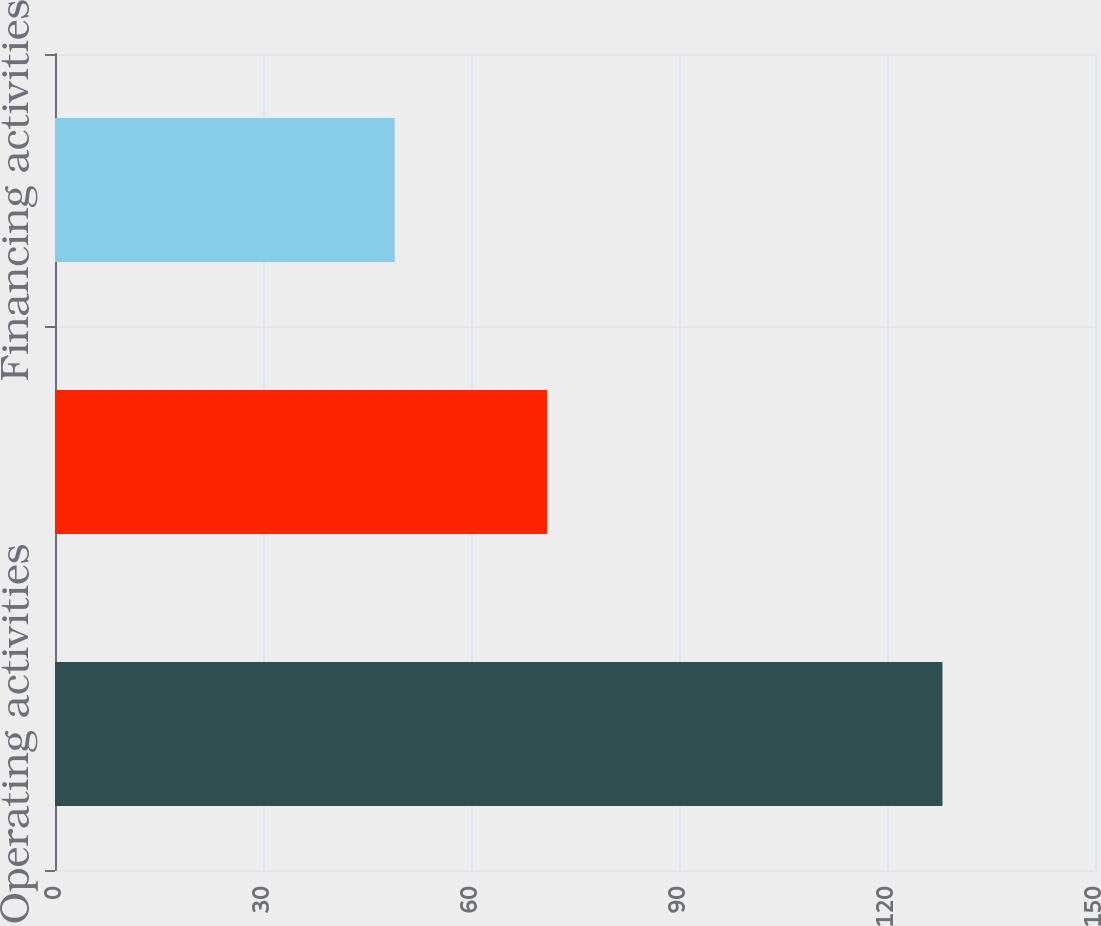<chart> <loc_0><loc_0><loc_500><loc_500><bar_chart><fcel>Operating activities<fcel>Investing activities<fcel>Financing activities<nl><fcel>128<fcel>71<fcel>49<nl></chart> 